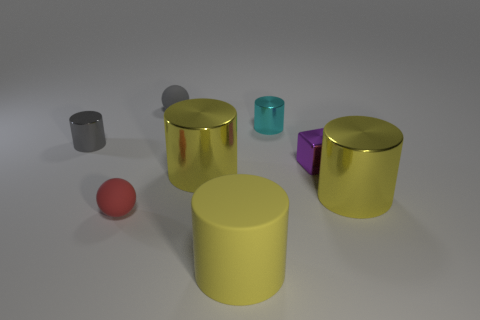Subtract all yellow balls. How many yellow cylinders are left? 3 Subtract all cyan cylinders. How many cylinders are left? 4 Subtract all cyan cylinders. How many cylinders are left? 4 Subtract all brown cylinders. Subtract all cyan spheres. How many cylinders are left? 5 Add 2 small purple metal blocks. How many objects exist? 10 Subtract all cylinders. How many objects are left? 3 Subtract all cylinders. Subtract all large yellow metal things. How many objects are left? 1 Add 4 tiny cyan objects. How many tiny cyan objects are left? 5 Add 2 small yellow metallic cylinders. How many small yellow metallic cylinders exist? 2 Subtract 1 gray spheres. How many objects are left? 7 